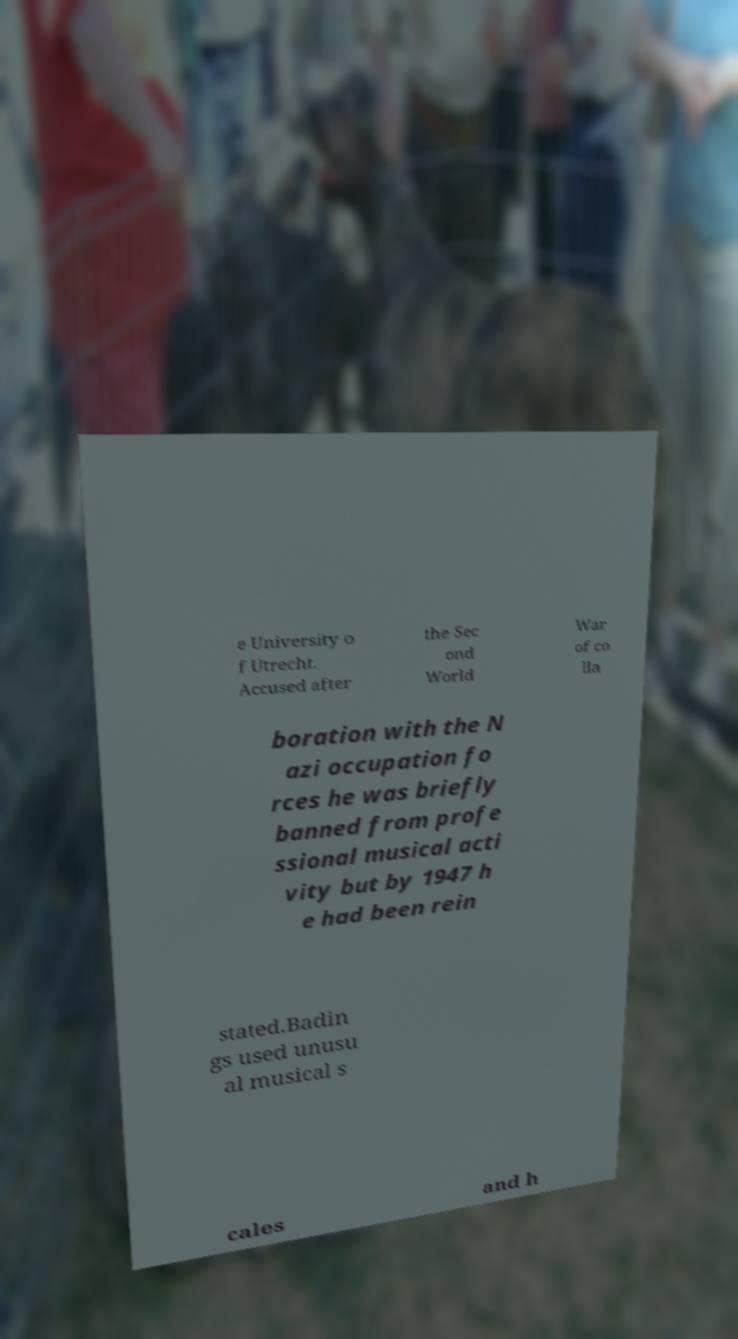I need the written content from this picture converted into text. Can you do that? e University o f Utrecht. Accused after the Sec ond World War of co lla boration with the N azi occupation fo rces he was briefly banned from profe ssional musical acti vity but by 1947 h e had been rein stated.Badin gs used unusu al musical s cales and h 